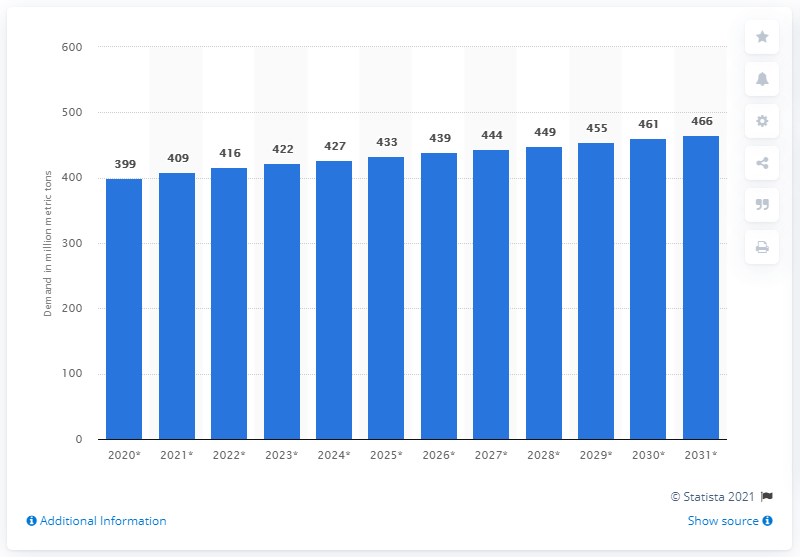Draw attention to some important aspects in this diagram. In 2020, the global consumption of paper and board was 399 million metric tons. The projected demand for paper and board in 2030 is expected to be 461. 